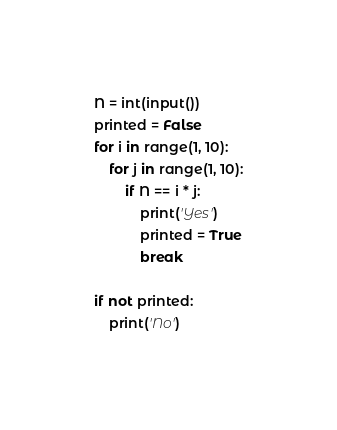<code> <loc_0><loc_0><loc_500><loc_500><_Python_>N = int(input())
printed = False
for i in range(1, 10):
    for j in range(1, 10):
        if N == i * j:
            print('Yes')
            printed = True
            break

if not printed:
    print('No')</code> 